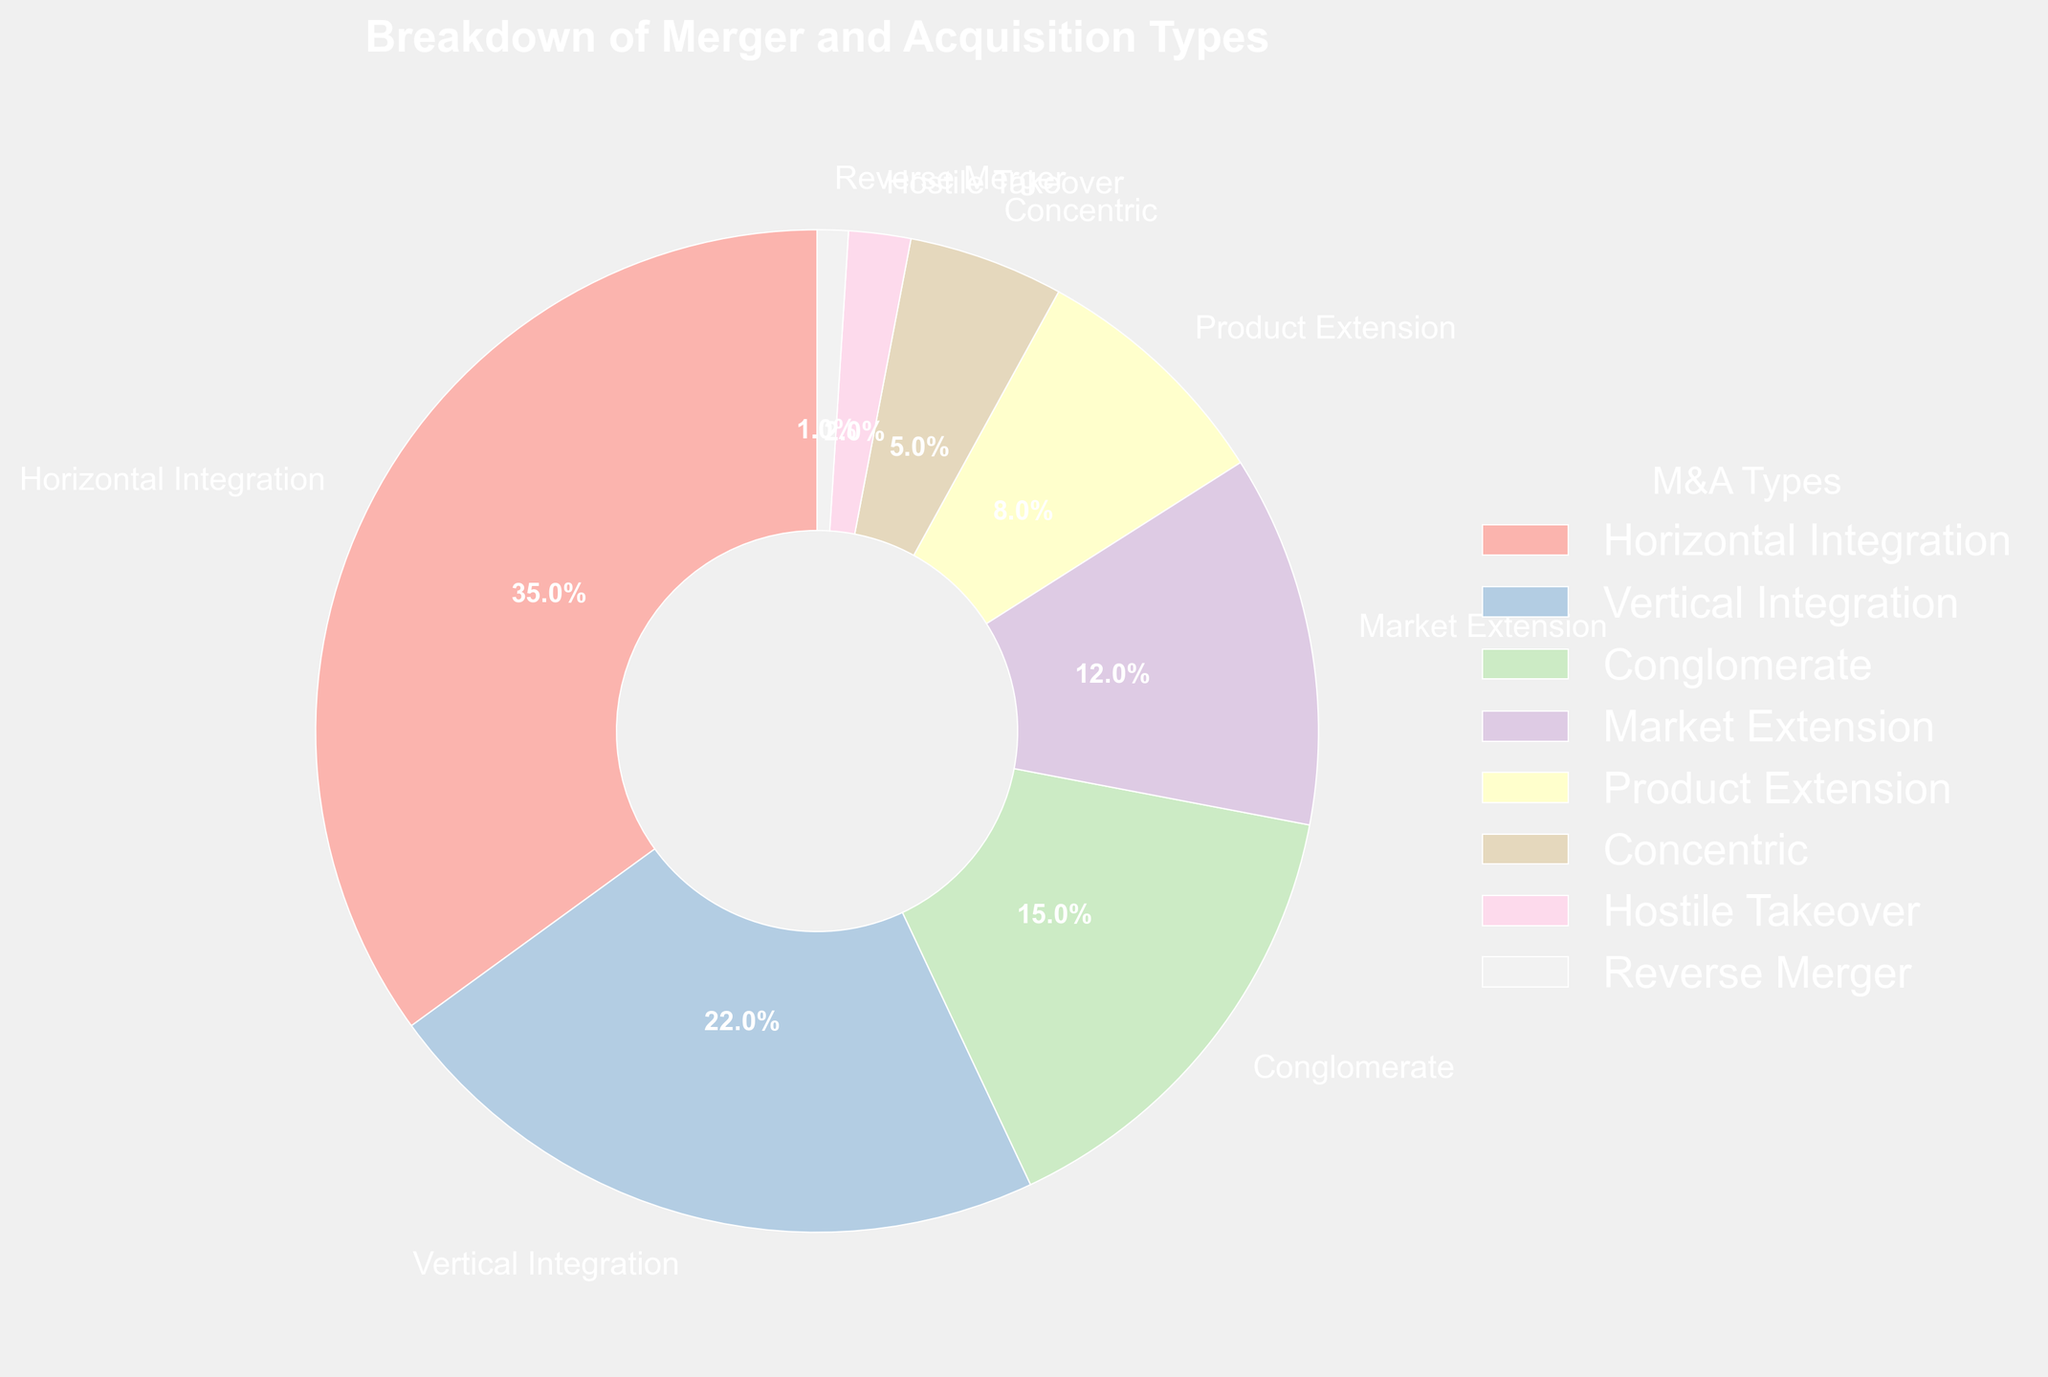What is the most common type of merger and acquisition shown in the chart? The chart shows that Horizontal Integration has the largest segment.
Answer: Horizontal Integration Which type of merger and acquisition represents the smallest proportion on the chart? The chart shows that Reverse Merger has the smallest segment.
Answer: Reverse Merger What is the combined percentage of Vertical Integration and Product Extension? Vertical Integration accounts for 22% and Product Extension accounts for 8%. Adding these two percentages together: 22 + 8 = 30.
Answer: 30% Is Horizontal Integration greater than or less than Conglomerate? By how much? Horizontal Integration is at 35% and Conglomerate is at 15%. Subtracting Conglomerate from Horizontal Integration: 35 - 15 = 20.
Answer: Greater by 20% How does Market Extension compare to Concentric in terms of their percentages? Market Extension is at 12% and Concentric is at 5%. Market Extension is greater.
Answer: Market Extension is greater Are the combined percentages of Hostile Takeover and Reverse Merger greater or less than Product Extension? Hostile Takeover is 2% and Reverse Merger is 1%. Combined they are 2 + 1 = 3%. Product Extension is 8%, so the combined percentage is less.
Answer: Less What is the total percentage represented by Concentric, Hostile Takeover, and Reverse Merger together? Concentric is 5%, Hostile Takeover is 2%, and Reverse Merger is 1%. Adding these three together: 5 + 2 + 1 = 8%.
Answer: 8% Which type of merger and acquisition is represented by the smallest wedge in terms of visual size? The smallest wedge in terms of size according to the pie chart visually is Reverse Merger, as it represents 1%.
Answer: Reverse Merger Sum the percentages for all merger and acquisition types excluding Horizontal Integration. The excluding percentages are 22% (Vertical Integration) + 15% (Conglomerate) + 12% (Market Extension) + 8% (Product Extension) + 5% (Concentric) + 2% (Hostile Takeover) + 1% (Reverse Merger). Adding these together: 22 + 15 + 12 + 8 + 5 + 2 + 1 = 65%.
Answer: 65% What is the visual difference in size between the Vertical Integration and Concentric wedges? Vertical Integration is represented by a larger wedge in the pie chart at 22%, whereas Concentric is much smaller at 5%.
Answer: Vertical Integration is visually larger 